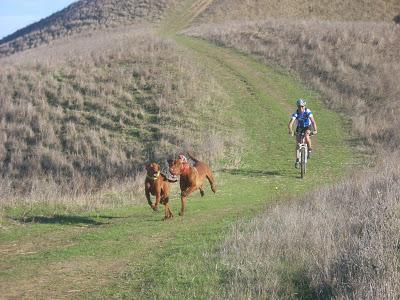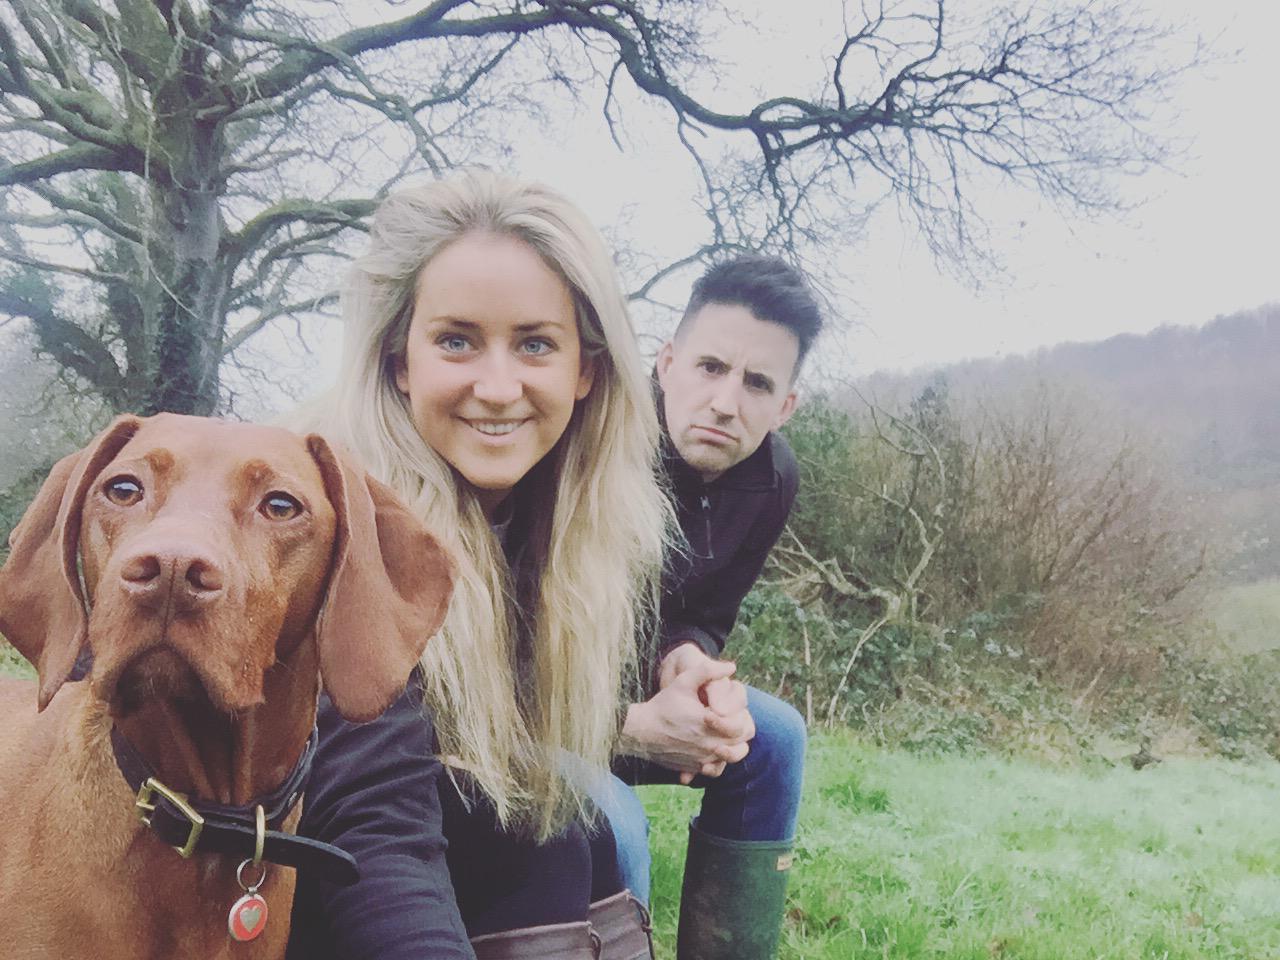The first image is the image on the left, the second image is the image on the right. Considering the images on both sides, is "One person is riding a bicycle near two dogs." valid? Answer yes or no. Yes. The first image is the image on the left, the second image is the image on the right. Assess this claim about the two images: "An image shows two red-orange dogs and a bike rider going down the same path.". Correct or not? Answer yes or no. Yes. 